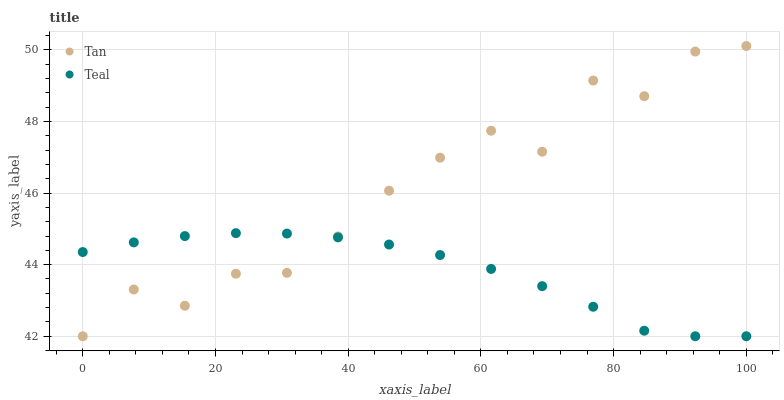Does Teal have the minimum area under the curve?
Answer yes or no. Yes. Does Tan have the maximum area under the curve?
Answer yes or no. Yes. Does Teal have the maximum area under the curve?
Answer yes or no. No. Is Teal the smoothest?
Answer yes or no. Yes. Is Tan the roughest?
Answer yes or no. Yes. Is Teal the roughest?
Answer yes or no. No. Does Tan have the lowest value?
Answer yes or no. Yes. Does Tan have the highest value?
Answer yes or no. Yes. Does Teal have the highest value?
Answer yes or no. No. Does Tan intersect Teal?
Answer yes or no. Yes. Is Tan less than Teal?
Answer yes or no. No. Is Tan greater than Teal?
Answer yes or no. No. 